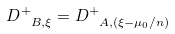<formula> <loc_0><loc_0><loc_500><loc_500>D ^ { + } _ { \ B , \xi } = D ^ { + } _ { \ A , ( \xi - \mu _ { 0 } / n ) }</formula> 